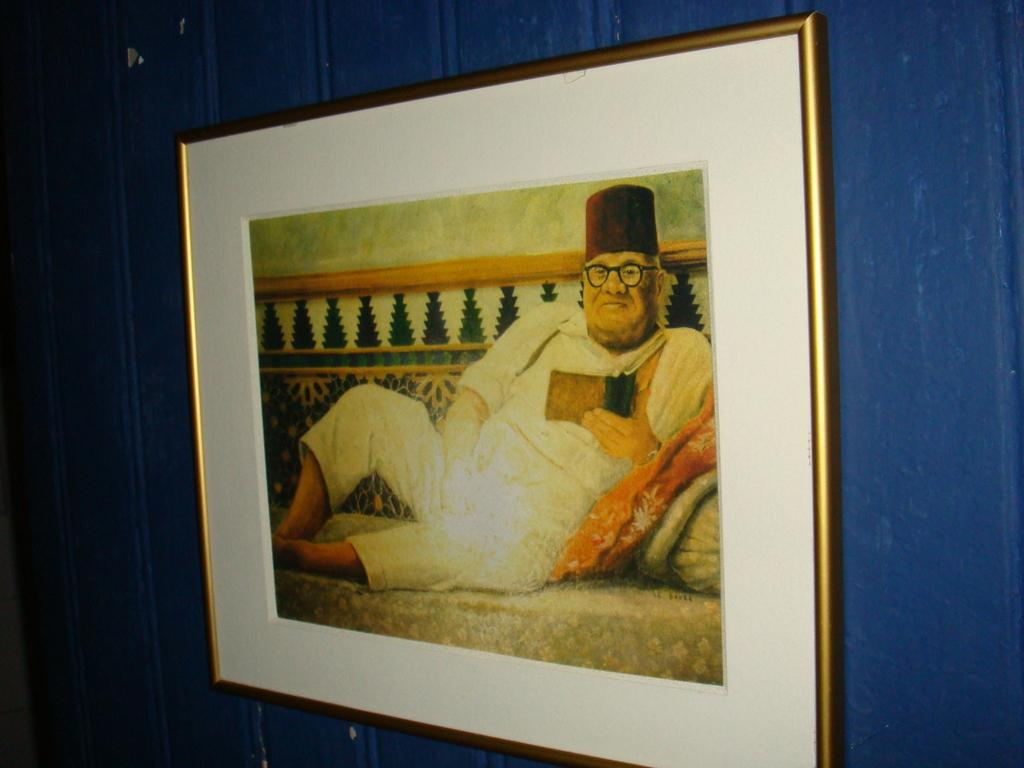What object is present in the image that is typically used for displaying photos? There is a photo frame in the image. Where is the photo frame located in the image? The photo frame is attached to the wall. What type of ring can be seen on the photo frame in the image? There is no ring present on the photo frame in the image. What point is being made by the photo frame in the image? The photo frame is not making any point in the image; it is simply an object used for displaying photos. 